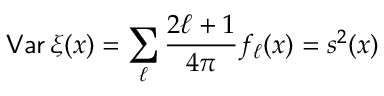Convert formula to latex. <formula><loc_0><loc_0><loc_500><loc_500>{ V a r } \, \xi ( x ) = \sum _ { \ell } \frac { 2 \ell + 1 } { 4 \pi } f _ { \ell } ( x ) = s ^ { 2 } ( x )</formula> 